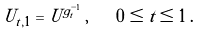<formula> <loc_0><loc_0><loc_500><loc_500>U _ { t , 1 } = U ^ { g _ { t } ^ { - 1 } } \, , \quad 0 \leq t \leq 1 \, .</formula> 